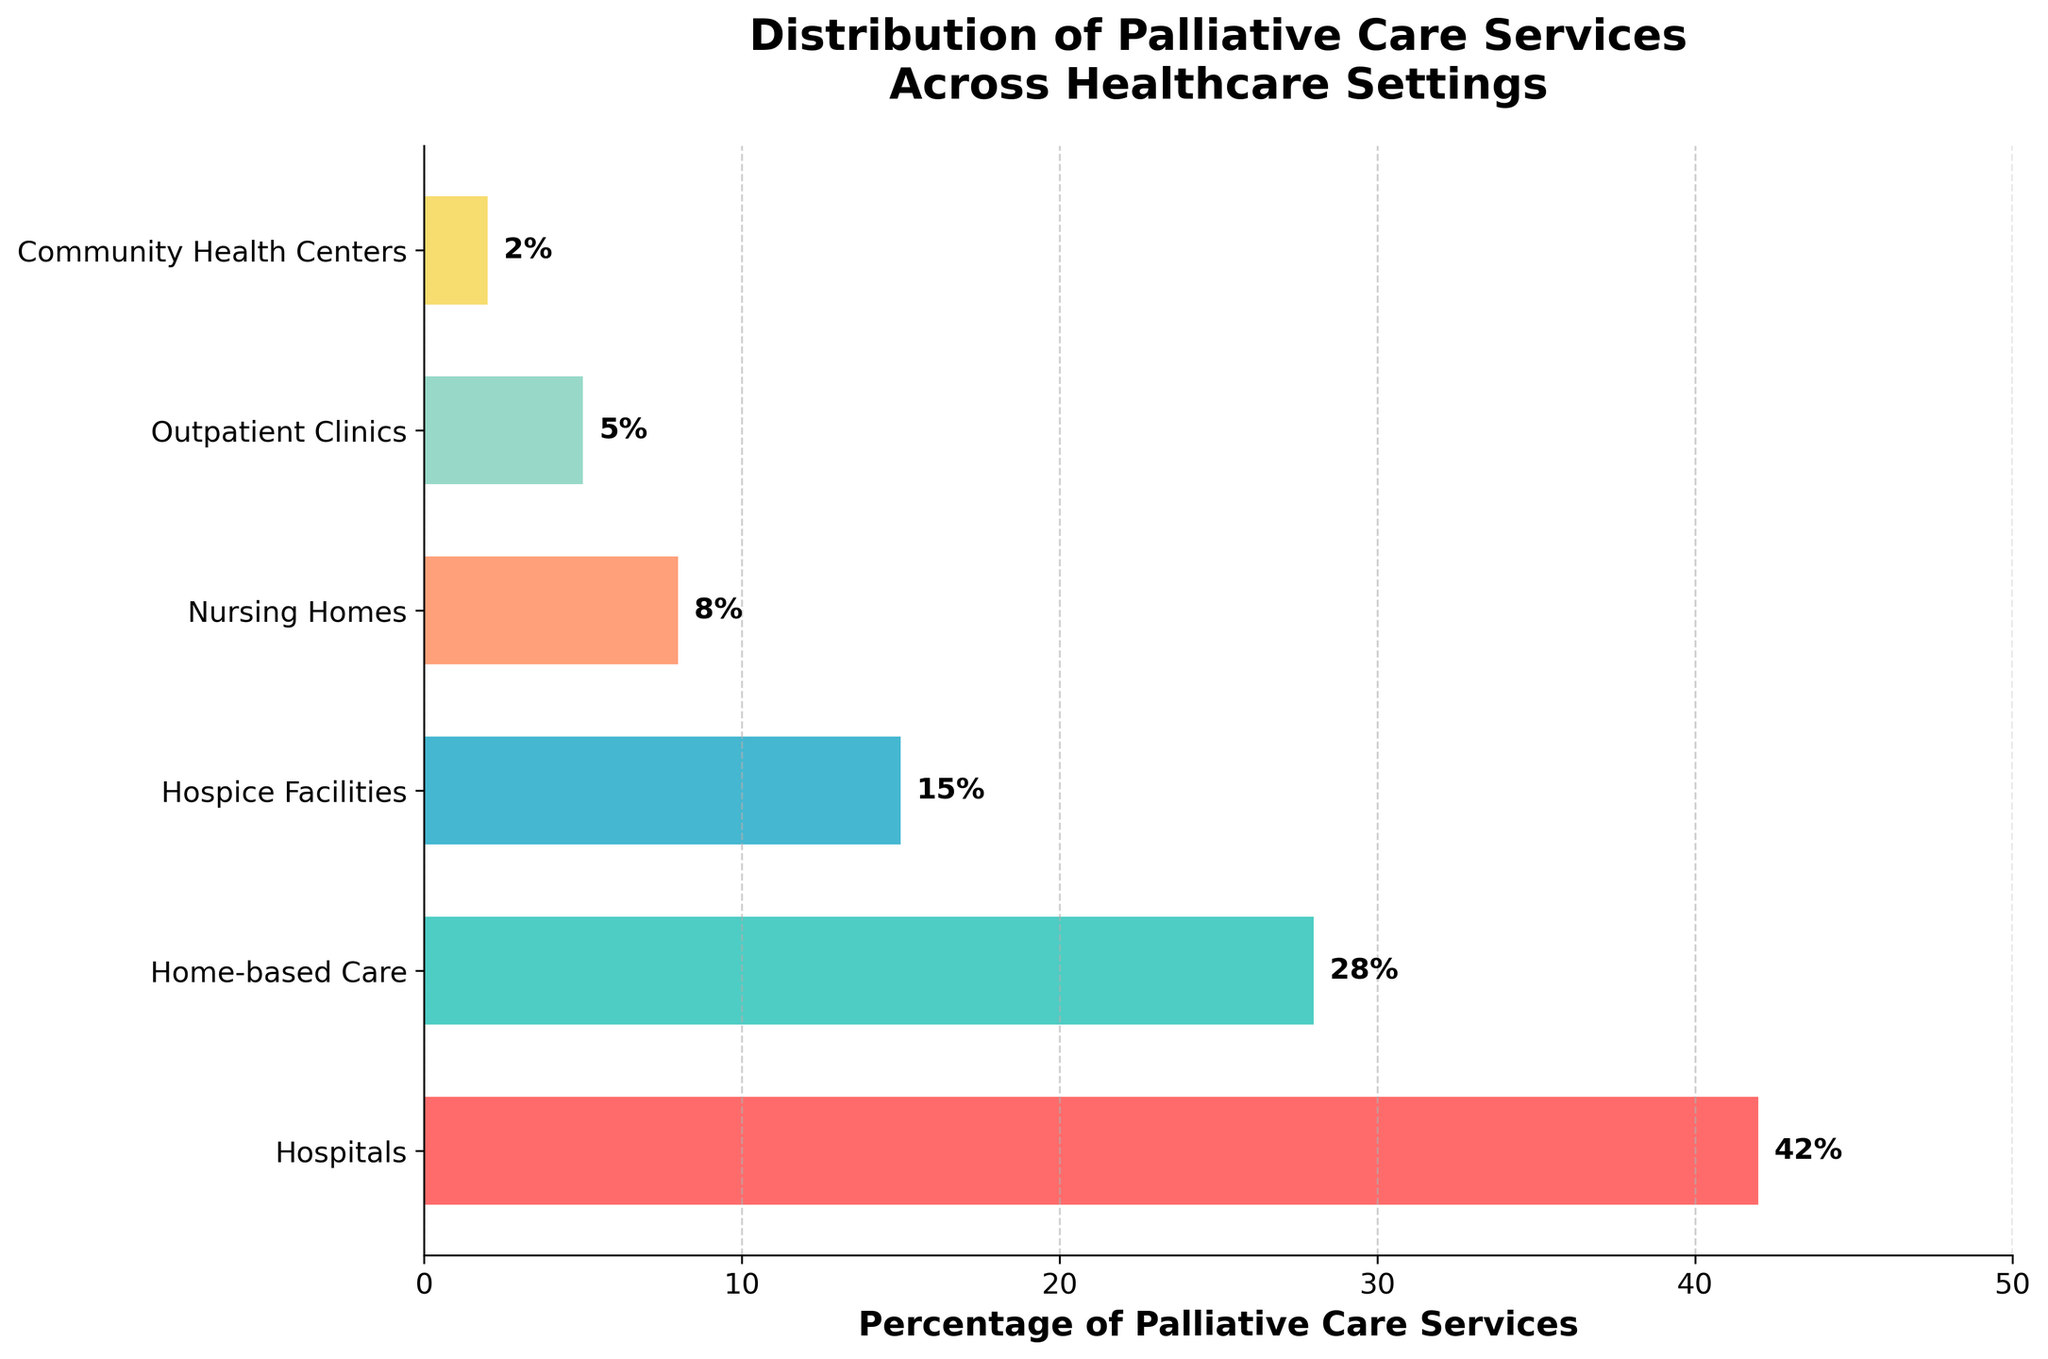Which healthcare setting provides the highest percentage of palliative care services? The bar chart shows the percentage of palliative care services for each setting. The tallest bar represents hospitals at 42%.
Answer: Hospitals What is the combined percentage of palliative care services provided by home-based care and hospice facilities? According to the chart, home-based care is at 28% and hospice facilities are at 15%. Adding these together gives 28% + 15% = 43%.
Answer: 43% Which setting provides the least percentage of palliative care services, and what is its percentage? The shortest bar in the chart represents community health centers, which is 2%.
Answer: Community Health Centers, 2% How much more is the percentage of palliative care services in nursing homes compared to outpatient clinics? The chart shows nursing homes at 8% and outpatient clinics at 5%. The difference is 8% - 5% = 3%.
Answer: 3% Which two settings combined have the same percentage of palliative care services as hospitals alone? Hospitals are at 42%. Combining home-based care (28%) and outpatient clinics (5%) which equals 33%, or home-based care (28%) and nursing homes (8%) which is 36%. We see that no two settings sum to exactly 42%, but the closest is home-based care and nursing homes at 36%, which are both significant contributors.
Answer: None, closest is home-based care and nursing homes at 36% Is the percentage of palliative care services in home-based care greater than that in nursing homes and outpatient clinics combined? Home-based care is 28%, nursing homes at 8% and outpatient clinics at 5%. Combined, 8% + 5% = 13%, which is less than 28%.
Answer: Yes Which setting has the second lowest percentage of palliative care services? The second shortest bar represents outpatient clinics at 5%.
Answer: Outpatient Clinics By what percentage is the palliative care service in hospitals greater than that in hospice facilities? Hospitals are at 42% while hospice facilities are at 15%. The difference is 42% - 15% = 27%.
Answer: 27% Between home-based care and outpatient clinics, which setting has a higher percentage of palliative care services, and by how much? Home-based care is 28% and outpatient clinics are 5%. The difference is 28% - 5% = 23%.
Answer: Home-based care, 23% 